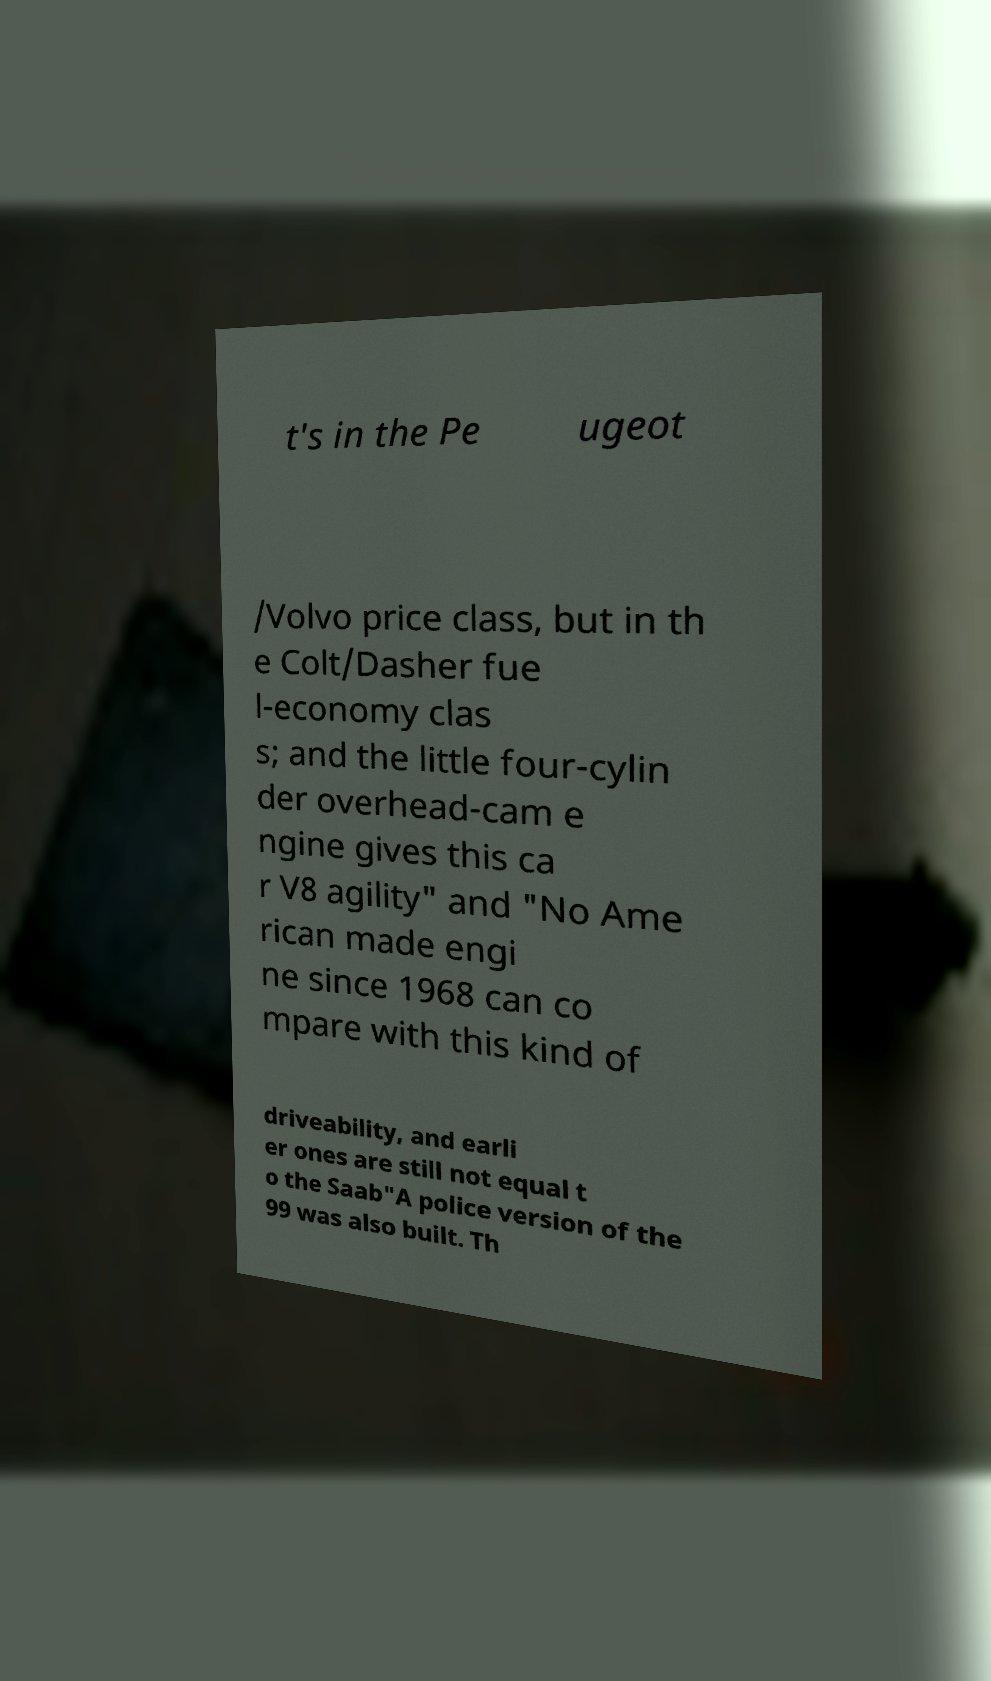Could you extract and type out the text from this image? t's in the Pe ugeot /Volvo price class, but in th e Colt/Dasher fue l-economy clas s; and the little four-cylin der overhead-cam e ngine gives this ca r V8 agility" and "No Ame rican made engi ne since 1968 can co mpare with this kind of driveability, and earli er ones are still not equal t o the Saab"A police version of the 99 was also built. Th 